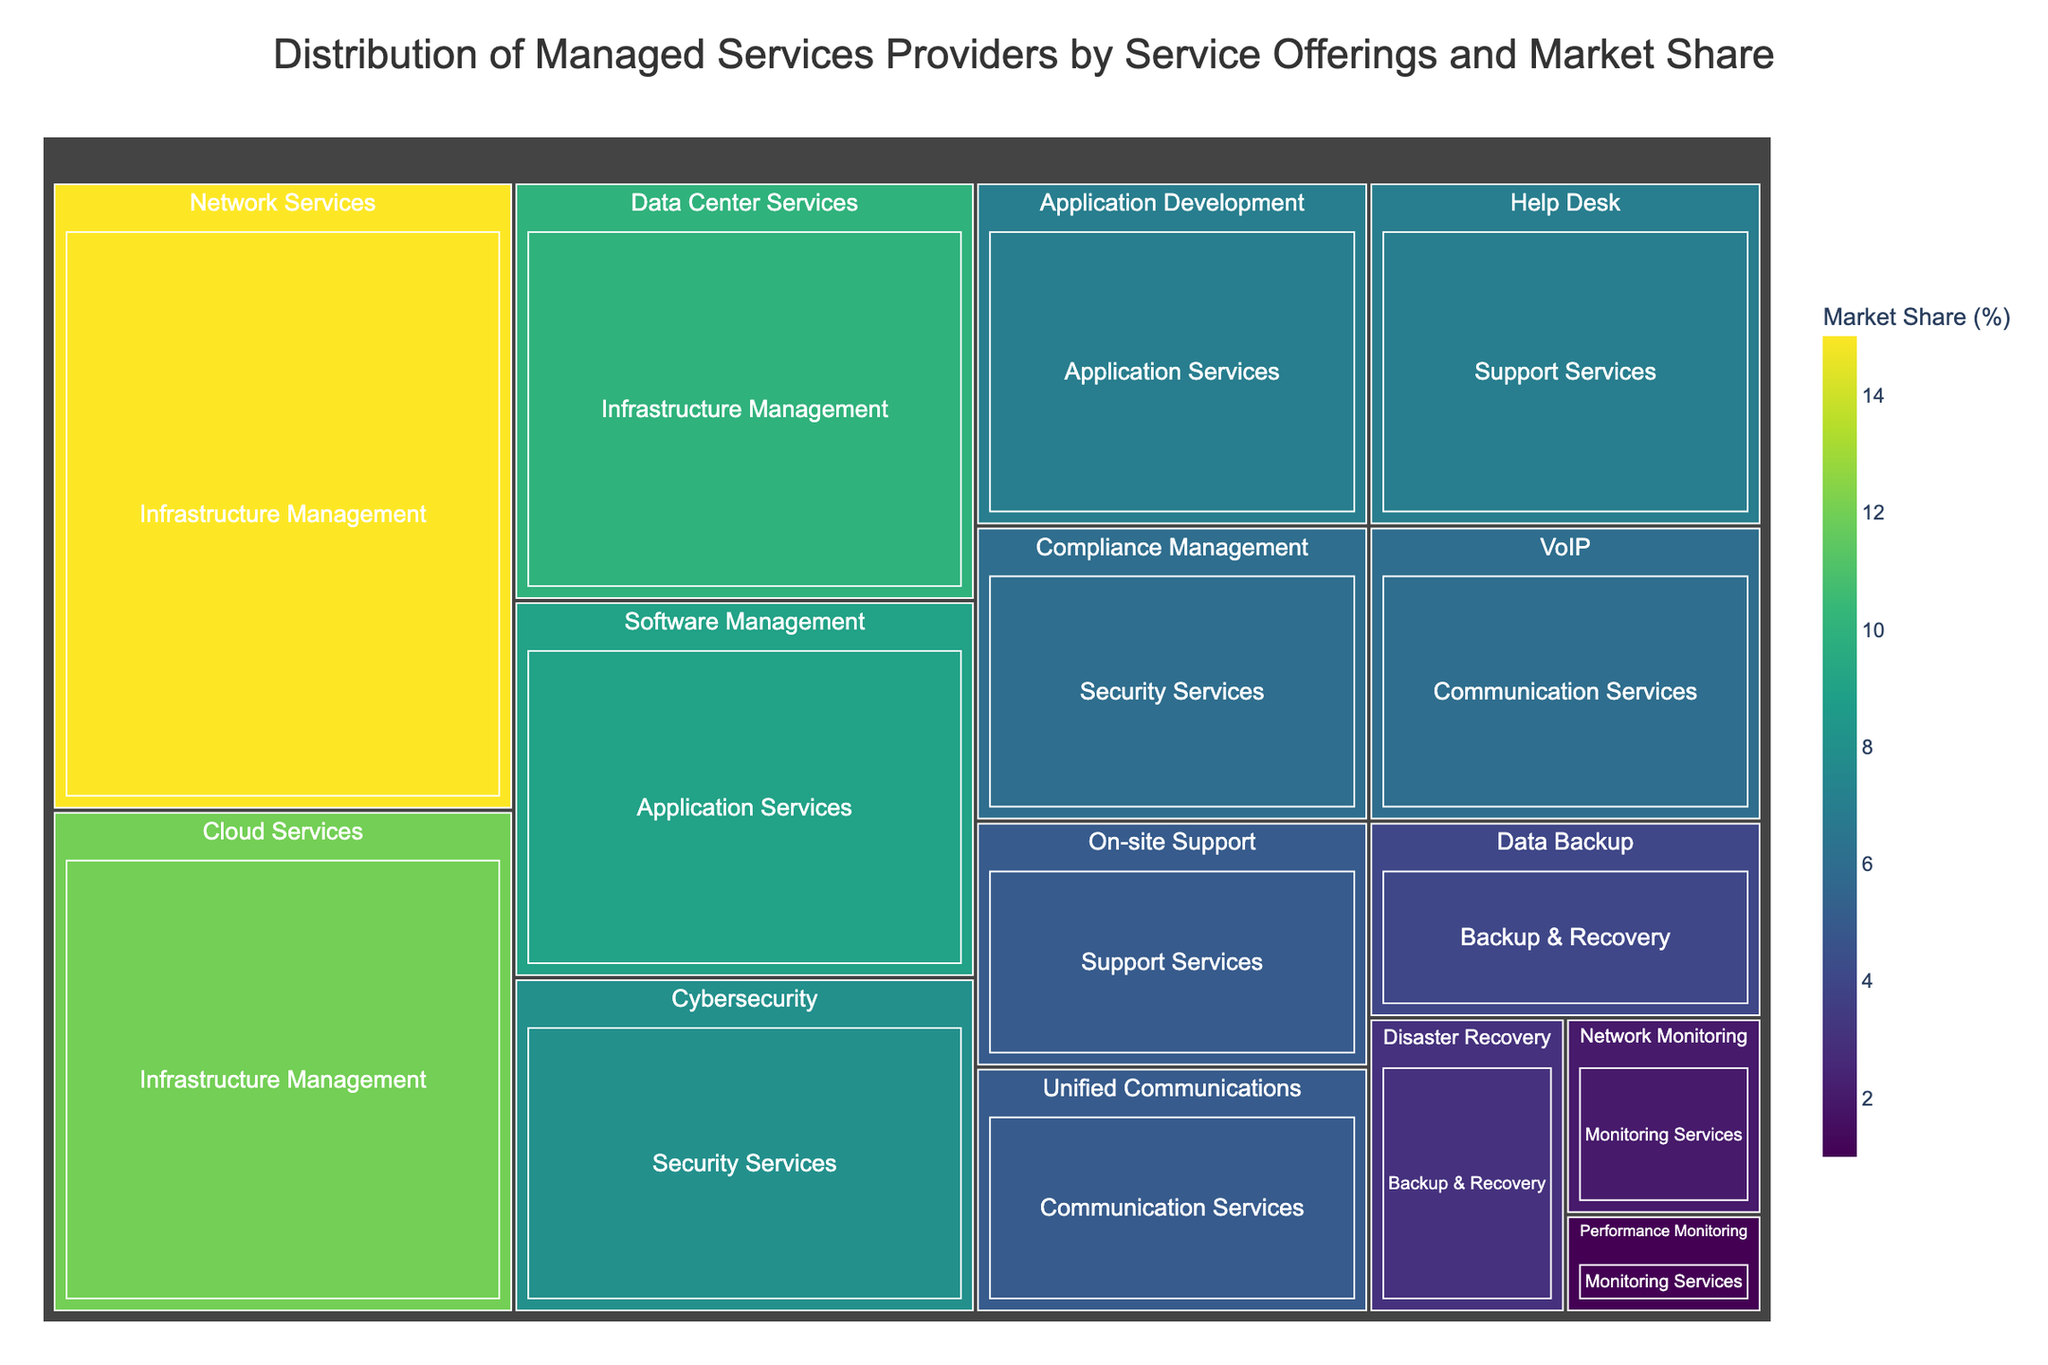What's the title of the treemap? The title is usually at the top of the figure and provides an overall description of what the visual represents.
Answer: Distribution of Managed Services Providers by Service Offerings and Market Share Which service category has the highest market share? In a treemap, the size of each tile represents the relative market share. The largest tiles belong to the "Infrastructure Management" category.
Answer: Infrastructure Management What is the market share of Cybersecurity services? Each tile in the treemap has a label and market share percentage. The Cybersecurity tile is under "Security Services" with a market share of 8%.
Answer: 8% How many service offerings contribute to the Infrastructure Management category? The treemap breaks down the main categories into smaller service offerings. Counting the distinct tiles under the "Infrastructure Management" section reveals three offerings: Network Services, Cloud Services, and Data Center Services.
Answer: 3 Which subcategory within Application Services has a higher market share? By comparing the sizes of the tiles under "Application Services," we see that "Software Management" has a larger size, representing 9% market share, compared to "Application Development" which has 7%.
Answer: Software Management What is the combined market share of the Backup & Recovery services? Add the market share percentages of "Data Backup" (4%) and "Disaster Recovery" (3%) under the Backup & Recovery category.
Answer: 7% How does the market share of VoIP compare to Unified Communications within Communication Services? The tiles for "VoIP" and "Unified Communications" under the "Communication Services" category can be compared. "VoIP" has a 6% market share, while "Unified Communications" has 5%.
Answer: VoIP has a 1% higher market share than Unified Communications Which service in the Security Services category has a lower market share? By looking at the label and corresponding sizes of the tiles in "Security Services," "Compliance Management" with a 6% market share is smaller than "Cybersecurity," which has an 8% market share.
Answer: Compliance Management What is the smallest service offering by market share in the treemap? Scan the entire treemap for the smallest tile. "Performance Monitoring" under "Monitoring Services" has the smallest market share at 1%.
Answer: Performance Monitoring What is the total market share of all services related to Security Services? Sum up the market shares of "Cybersecurity" (8%) and "Compliance Management" (6%).
Answer: 14% 